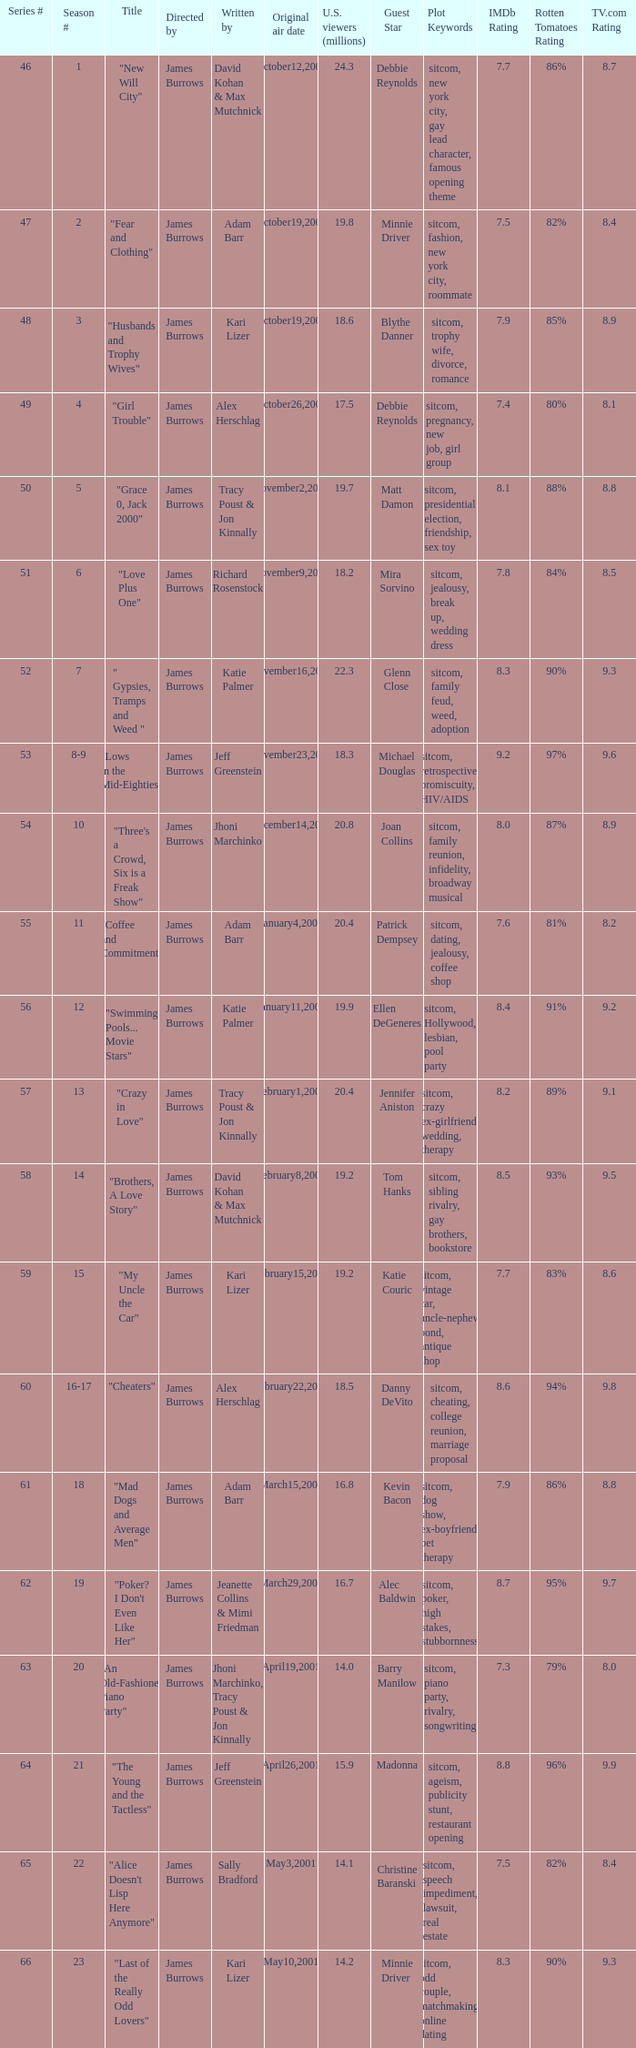Who wrote the episode titled "An Old-fashioned Piano Party"? Jhoni Marchinko, Tracy Poust & Jon Kinnally. 